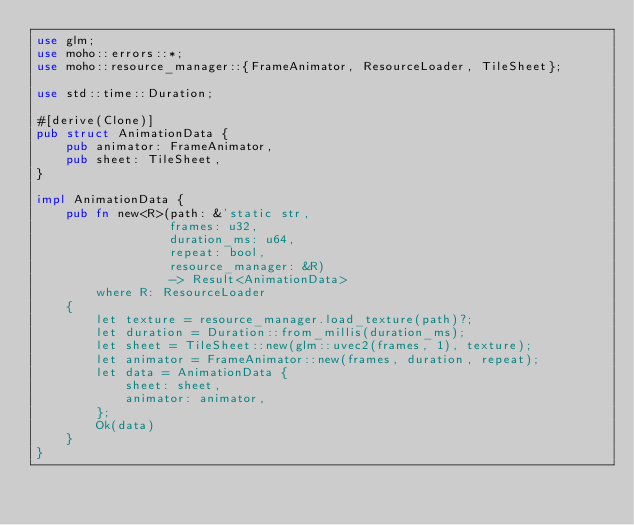<code> <loc_0><loc_0><loc_500><loc_500><_Rust_>use glm;
use moho::errors::*;
use moho::resource_manager::{FrameAnimator, ResourceLoader, TileSheet};

use std::time::Duration;

#[derive(Clone)]
pub struct AnimationData {
    pub animator: FrameAnimator,
    pub sheet: TileSheet,
}

impl AnimationData {
    pub fn new<R>(path: &'static str,
                  frames: u32,
                  duration_ms: u64,
                  repeat: bool,
                  resource_manager: &R)
                  -> Result<AnimationData>
        where R: ResourceLoader
    {
        let texture = resource_manager.load_texture(path)?;
        let duration = Duration::from_millis(duration_ms);
        let sheet = TileSheet::new(glm::uvec2(frames, 1), texture);
        let animator = FrameAnimator::new(frames, duration, repeat);
        let data = AnimationData {
            sheet: sheet,
            animator: animator,
        };
        Ok(data)
    }
}
</code> 